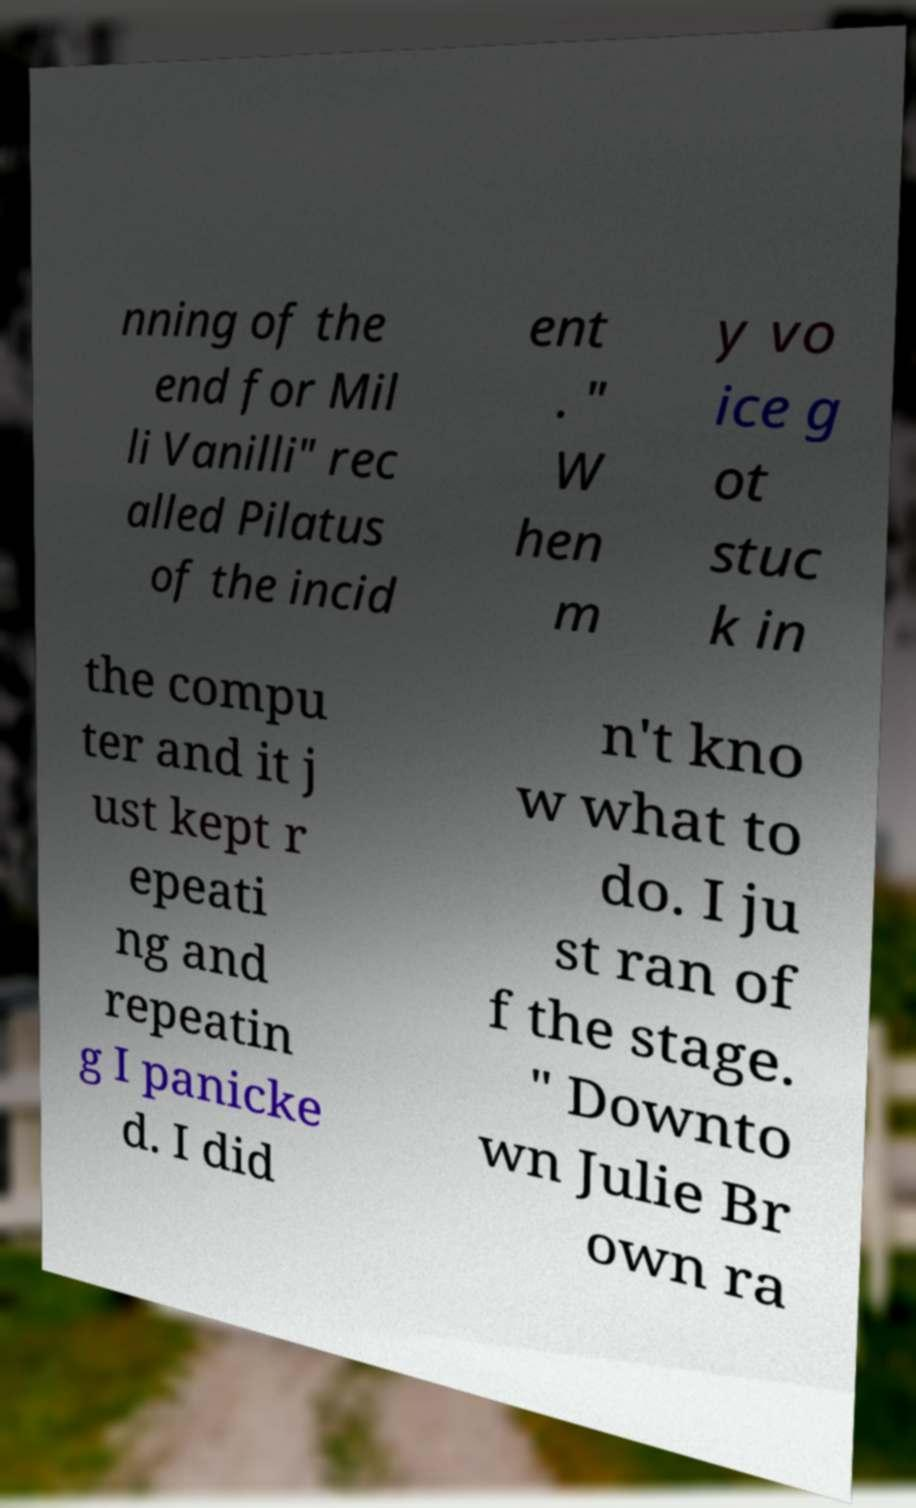Could you assist in decoding the text presented in this image and type it out clearly? nning of the end for Mil li Vanilli" rec alled Pilatus of the incid ent . " W hen m y vo ice g ot stuc k in the compu ter and it j ust kept r epeati ng and repeatin g I panicke d. I did n't kno w what to do. I ju st ran of f the stage. " Downto wn Julie Br own ra 